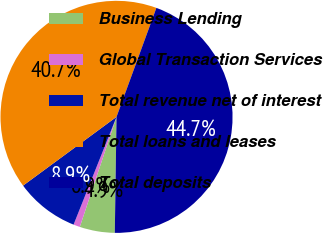Convert chart to OTSL. <chart><loc_0><loc_0><loc_500><loc_500><pie_chart><fcel>Business Lending<fcel>Global Transaction Services<fcel>Total revenue net of interest<fcel>Total loans and leases<fcel>Total deposits<nl><fcel>4.89%<fcel>0.91%<fcel>8.87%<fcel>40.68%<fcel>44.66%<nl></chart> 